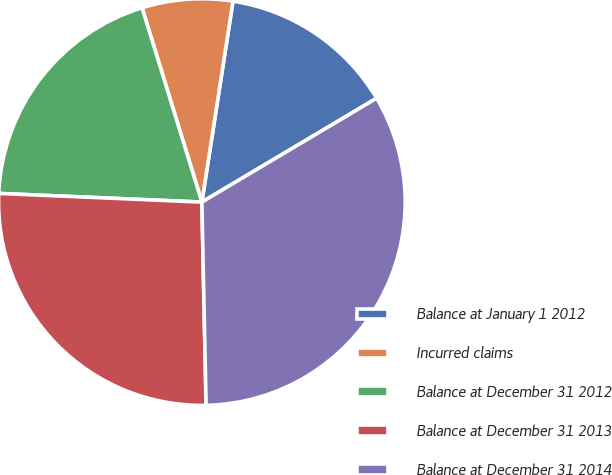<chart> <loc_0><loc_0><loc_500><loc_500><pie_chart><fcel>Balance at January 1 2012<fcel>Incurred claims<fcel>Balance at December 31 2012<fcel>Balance at December 31 2013<fcel>Balance at December 31 2014<nl><fcel>14.02%<fcel>7.2%<fcel>19.57%<fcel>26.01%<fcel>33.21%<nl></chart> 